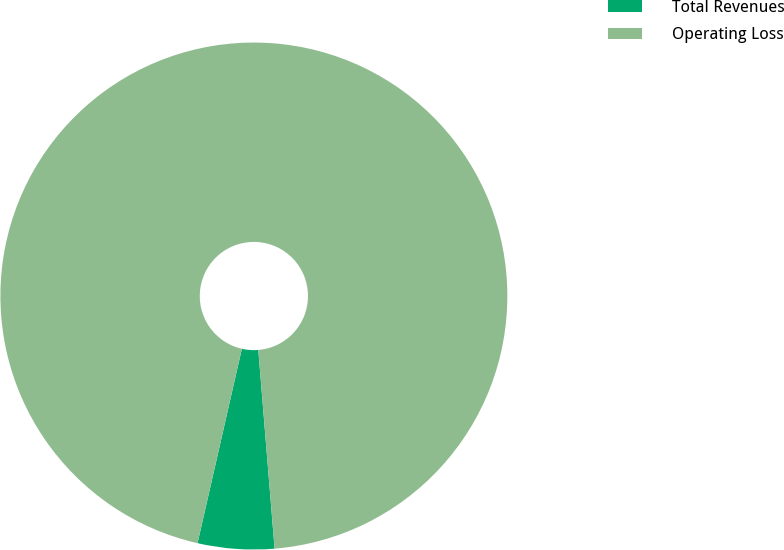Convert chart. <chart><loc_0><loc_0><loc_500><loc_500><pie_chart><fcel>Total Revenues<fcel>Operating Loss<nl><fcel>4.87%<fcel>95.13%<nl></chart> 